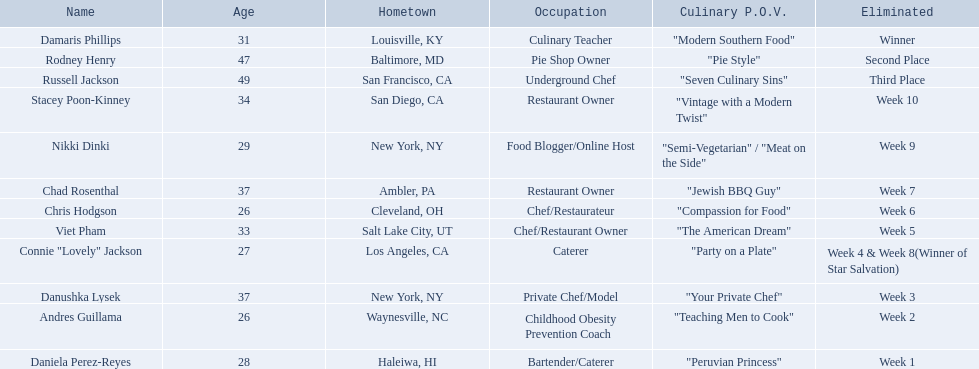Who are the contestants? Damaris Phillips, 31, Rodney Henry, 47, Russell Jackson, 49, Stacey Poon-Kinney, 34, Nikki Dinki, 29, Chad Rosenthal, 37, Chris Hodgson, 26, Viet Pham, 33, Connie "Lovely" Jackson, 27, Danushka Lysek, 37, Andres Guillama, 26, Daniela Perez-Reyes, 28. How old is chris hodgson? 26. Which other contestant has that age? Andres Guillama. 